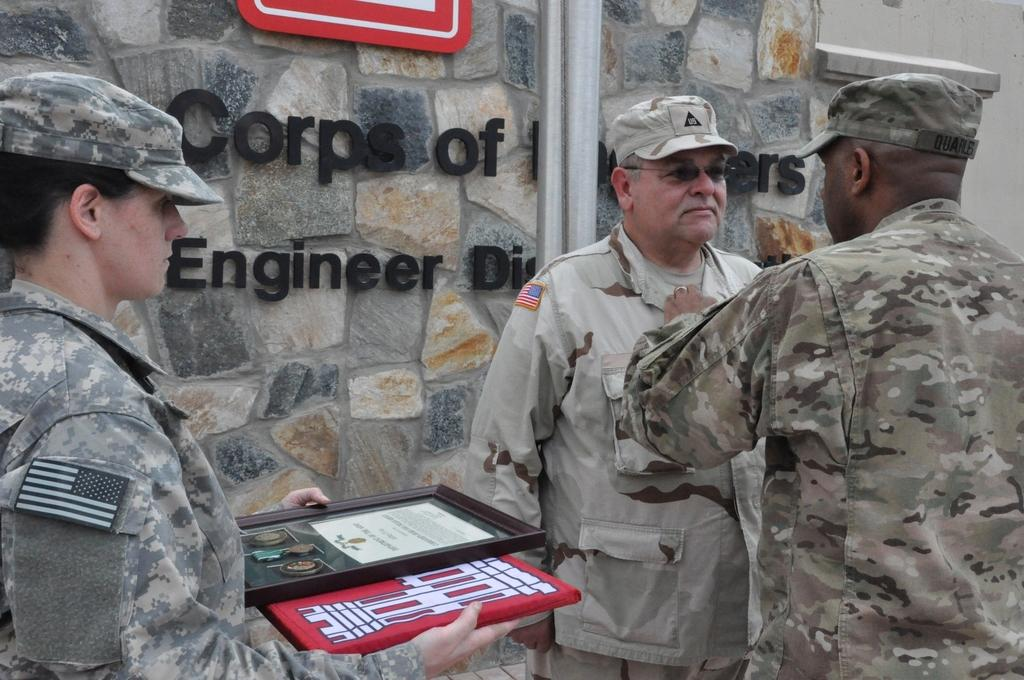How many people are in the image? There are two men in the image. Where are the men located in the image? The men are standing on the right side of the image. What are the men wearing? The men are wearing dresses. What can be seen in the middle of the image? There is a stone wall in the middle of the image. What type of wool can be seen in the image? There is no wool present in the image. Can you describe the veins in the image? There are no veins visible in the image. 